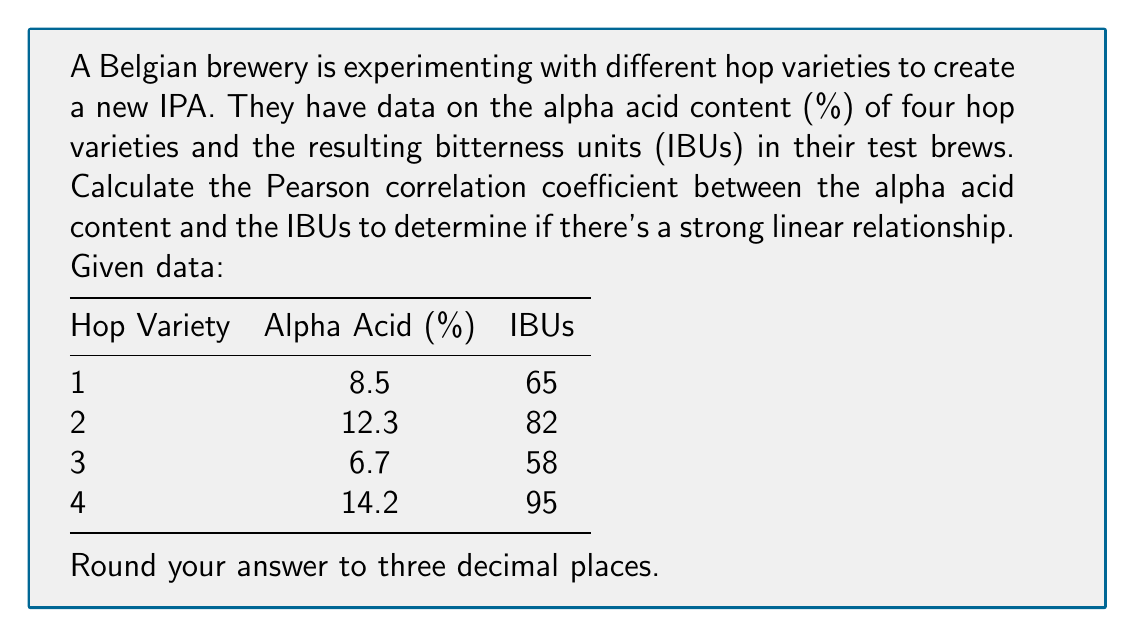Solve this math problem. To calculate the Pearson correlation coefficient (r), we'll use the formula:

$$ r = \frac{\sum_{i=1}^{n} (x_i - \bar{x})(y_i - \bar{y})}{\sqrt{\sum_{i=1}^{n} (x_i - \bar{x})^2 \sum_{i=1}^{n} (y_i - \bar{y})^2}} $$

Where $x_i$ are the alpha acid percentages and $y_i$ are the IBU values.

Step 1: Calculate means
$\bar{x} = \frac{8.5 + 12.3 + 6.7 + 14.2}{4} = 10.425$
$\bar{y} = \frac{65 + 82 + 58 + 95}{4} = 75$

Step 2: Calculate $(x_i - \bar{x})$ and $(y_i - \bar{y})$ for each pair
1: (-1.925, -10)
2: (1.875, 7)
3: (-3.725, -17)
4: (3.775, 20)

Step 3: Calculate $(x_i - \bar{x})(y_i - \bar{y})$ for each pair
1: 19.25
2: 13.125
3: 63.325
4: 75.5

Step 4: Sum the results from step 3
$\sum_{i=1}^{n} (x_i - \bar{x})(y_i - \bar{y}) = 171.2$

Step 5: Calculate $(x_i - \bar{x})^2$ and $(y_i - \bar{y})^2$ for each pair
1: (3.705625, 100)
2: (3.515625, 49)
3: (13.875625, 289)
4: (14.250625, 400)

Step 6: Sum the results from step 5
$\sum_{i=1}^{n} (x_i - \bar{x})^2 = 35.3475$
$\sum_{i=1}^{n} (y_i - \bar{y})^2 = 838$

Step 7: Apply the formula
$$ r = \frac{171.2}{\sqrt{35.3475 \times 838}} = \frac{171.2}{172.023} = 0.9952 $$

Rounded to three decimal places: 0.995
Answer: 0.995 